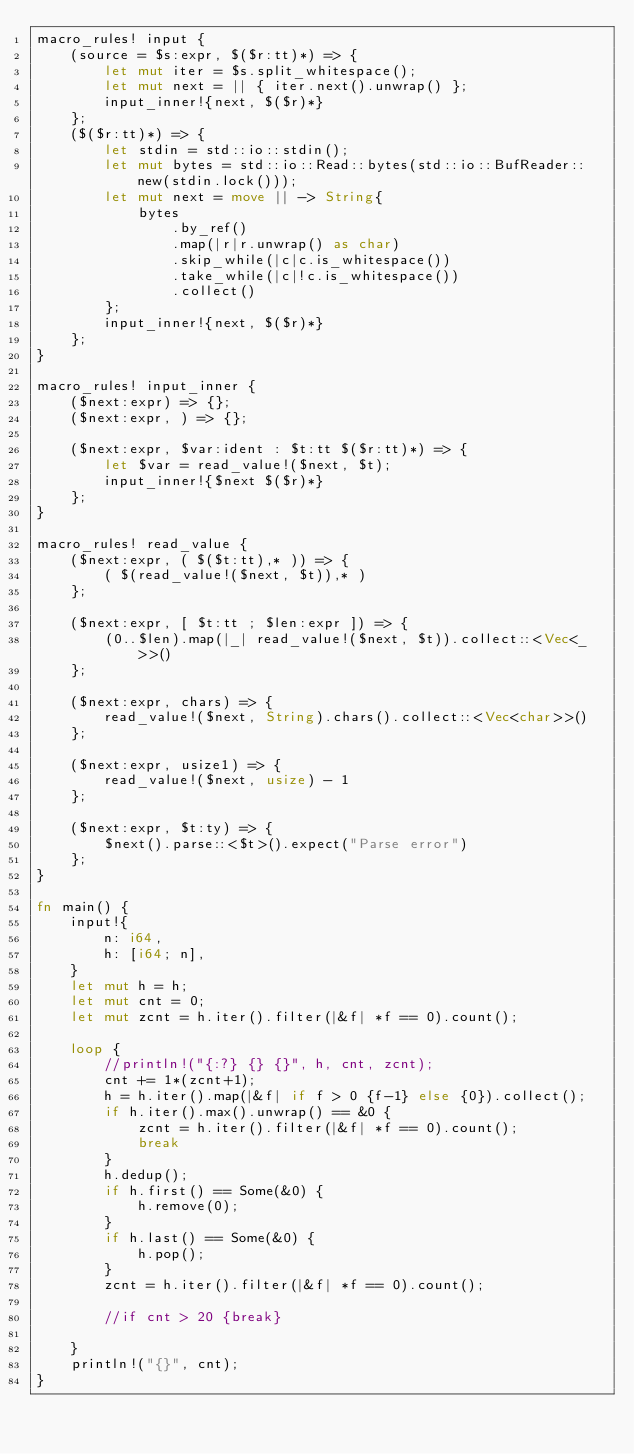Convert code to text. <code><loc_0><loc_0><loc_500><loc_500><_Rust_>macro_rules! input {
    (source = $s:expr, $($r:tt)*) => {
        let mut iter = $s.split_whitespace();
        let mut next = || { iter.next().unwrap() };
        input_inner!{next, $($r)*}
    };
    ($($r:tt)*) => {
        let stdin = std::io::stdin();
        let mut bytes = std::io::Read::bytes(std::io::BufReader::new(stdin.lock()));
        let mut next = move || -> String{
            bytes
                .by_ref()
                .map(|r|r.unwrap() as char)
                .skip_while(|c|c.is_whitespace())
                .take_while(|c|!c.is_whitespace())
                .collect()
        };
        input_inner!{next, $($r)*}
    };
}

macro_rules! input_inner {
    ($next:expr) => {};
    ($next:expr, ) => {};

    ($next:expr, $var:ident : $t:tt $($r:tt)*) => {
        let $var = read_value!($next, $t);
        input_inner!{$next $($r)*}
    };
}

macro_rules! read_value {
    ($next:expr, ( $($t:tt),* )) => {
        ( $(read_value!($next, $t)),* )
    };

    ($next:expr, [ $t:tt ; $len:expr ]) => {
        (0..$len).map(|_| read_value!($next, $t)).collect::<Vec<_>>()
    };

    ($next:expr, chars) => {
        read_value!($next, String).chars().collect::<Vec<char>>()
    };

    ($next:expr, usize1) => {
        read_value!($next, usize) - 1
    };

    ($next:expr, $t:ty) => {
        $next().parse::<$t>().expect("Parse error")
    };
}

fn main() {
    input!{
        n: i64,
        h: [i64; n],
    }
    let mut h = h;
    let mut cnt = 0;
    let mut zcnt = h.iter().filter(|&f| *f == 0).count();

    loop {
        //println!("{:?} {} {}", h, cnt, zcnt);
        cnt += 1*(zcnt+1);
        h = h.iter().map(|&f| if f > 0 {f-1} else {0}).collect();
        if h.iter().max().unwrap() == &0 {
            zcnt = h.iter().filter(|&f| *f == 0).count();
            break
        }
        h.dedup();
        if h.first() == Some(&0) {
            h.remove(0);
        }
        if h.last() == Some(&0) {
            h.pop();
        }
        zcnt = h.iter().filter(|&f| *f == 0).count();
        
        //if cnt > 20 {break}
        
    }
    println!("{}", cnt);
}
</code> 